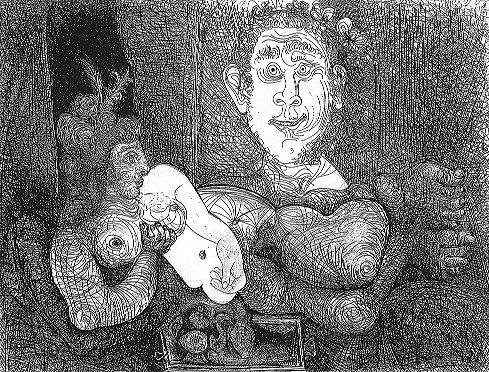Investigate the use of animals with human features in this artwork. What might the artist be suggesting through these hybrid creatures? The integration of animals with human features in this artwork could be suggesting several themes. These hybrid creatures might represent the merging of different realms of existence, such as the natural and the human or the conscious and subconscious. By blurring the boundaries between the animal and human, the artist may be challenging our perceptions of humanity and urging us to consider the fluidity and interconnectedness of life forms. Such imagery might also speak to the idea of transformation or evolution, both psychological and physical, or could symbolize the inherent wildness within the human psyche. 